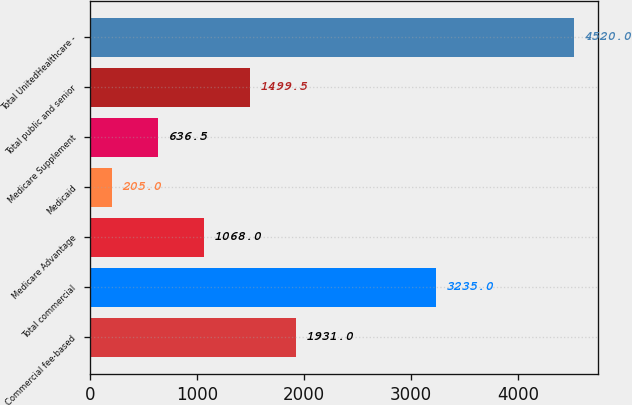Convert chart. <chart><loc_0><loc_0><loc_500><loc_500><bar_chart><fcel>Commercial fee-based<fcel>Total commercial<fcel>Medicare Advantage<fcel>Medicaid<fcel>Medicare Supplement<fcel>Total public and senior<fcel>Total UnitedHealthcare -<nl><fcel>1931<fcel>3235<fcel>1068<fcel>205<fcel>636.5<fcel>1499.5<fcel>4520<nl></chart> 